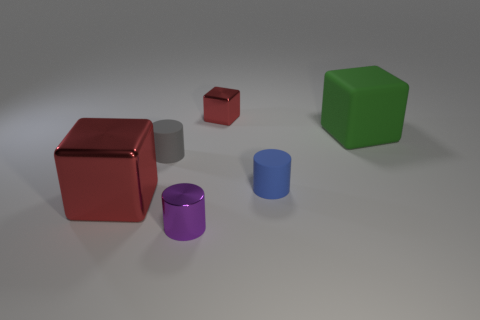Are there any small metal blocks of the same color as the big shiny block?
Your answer should be compact. Yes. Is the number of rubber cubes that are to the left of the small blue matte cylinder less than the number of tiny blue matte things that are behind the tiny metal cylinder?
Your answer should be compact. Yes. The block on the right side of the thing behind the big thing behind the large red shiny object is made of what material?
Keep it short and to the point. Rubber. What is the size of the metal object that is in front of the large matte block and behind the metallic cylinder?
Offer a terse response. Large. What number of spheres are either blue matte things or tiny purple matte objects?
Ensure brevity in your answer.  0. There is another rubber object that is the same size as the blue thing; what color is it?
Give a very brief answer. Gray. Is there anything else that has the same shape as the small blue matte object?
Ensure brevity in your answer.  Yes. There is a small shiny object that is the same shape as the big metallic thing; what is its color?
Your answer should be very brief. Red. How many objects are either red blocks or small cylinders that are behind the small metallic cylinder?
Provide a short and direct response. 4. Are there fewer green cubes in front of the blue rubber thing than tiny matte objects?
Your answer should be very brief. Yes. 